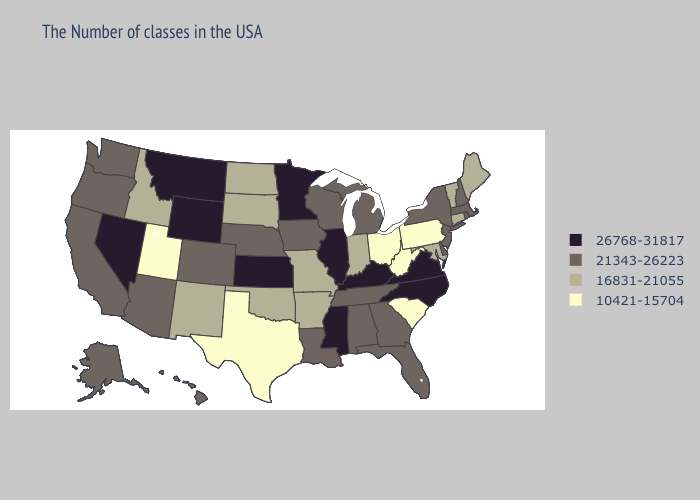What is the lowest value in the South?
Concise answer only. 10421-15704. Does Kentucky have a higher value than Minnesota?
Keep it brief. No. Name the states that have a value in the range 10421-15704?
Keep it brief. Pennsylvania, South Carolina, West Virginia, Ohio, Texas, Utah. What is the value of Indiana?
Answer briefly. 16831-21055. Does Massachusetts have a higher value than Rhode Island?
Short answer required. No. Name the states that have a value in the range 26768-31817?
Concise answer only. Virginia, North Carolina, Kentucky, Illinois, Mississippi, Minnesota, Kansas, Wyoming, Montana, Nevada. Name the states that have a value in the range 10421-15704?
Write a very short answer. Pennsylvania, South Carolina, West Virginia, Ohio, Texas, Utah. What is the value of Nevada?
Be succinct. 26768-31817. Among the states that border Colorado , does New Mexico have the highest value?
Concise answer only. No. What is the highest value in the USA?
Answer briefly. 26768-31817. What is the lowest value in the West?
Short answer required. 10421-15704. Name the states that have a value in the range 26768-31817?
Short answer required. Virginia, North Carolina, Kentucky, Illinois, Mississippi, Minnesota, Kansas, Wyoming, Montana, Nevada. Name the states that have a value in the range 26768-31817?
Short answer required. Virginia, North Carolina, Kentucky, Illinois, Mississippi, Minnesota, Kansas, Wyoming, Montana, Nevada. Name the states that have a value in the range 10421-15704?
Concise answer only. Pennsylvania, South Carolina, West Virginia, Ohio, Texas, Utah. What is the value of Kentucky?
Short answer required. 26768-31817. 